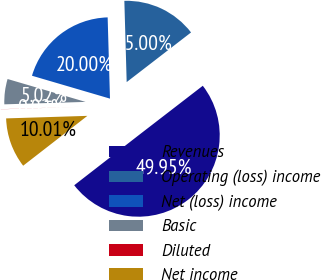Convert chart to OTSL. <chart><loc_0><loc_0><loc_500><loc_500><pie_chart><fcel>Revenues<fcel>Operating (loss) income<fcel>Net (loss) income<fcel>Basic<fcel>Diluted<fcel>Net income<nl><fcel>49.95%<fcel>15.0%<fcel>20.0%<fcel>5.02%<fcel>0.02%<fcel>10.01%<nl></chart> 